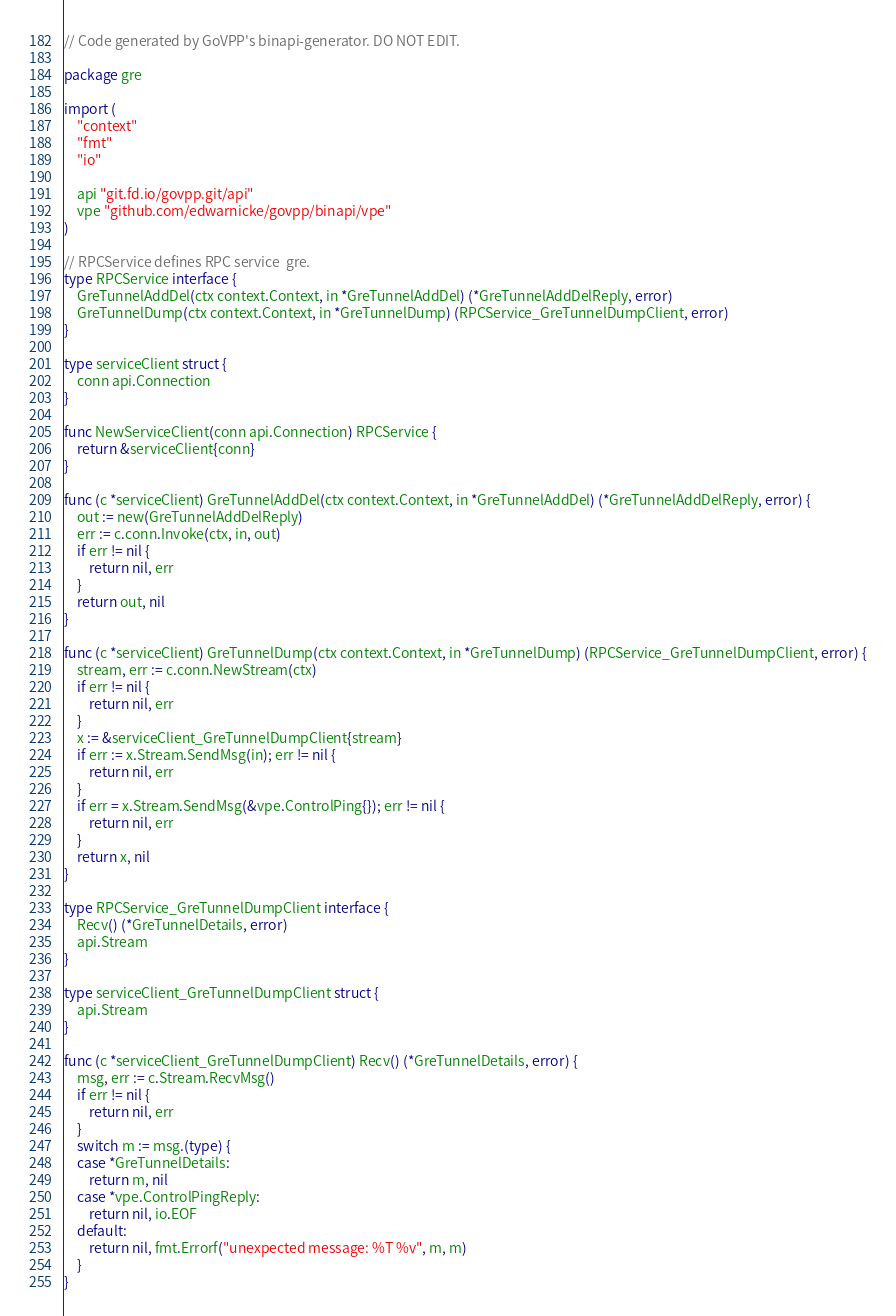<code> <loc_0><loc_0><loc_500><loc_500><_Go_>// Code generated by GoVPP's binapi-generator. DO NOT EDIT.

package gre

import (
	"context"
	"fmt"
	"io"

	api "git.fd.io/govpp.git/api"
	vpe "github.com/edwarnicke/govpp/binapi/vpe"
)

// RPCService defines RPC service  gre.
type RPCService interface {
	GreTunnelAddDel(ctx context.Context, in *GreTunnelAddDel) (*GreTunnelAddDelReply, error)
	GreTunnelDump(ctx context.Context, in *GreTunnelDump) (RPCService_GreTunnelDumpClient, error)
}

type serviceClient struct {
	conn api.Connection
}

func NewServiceClient(conn api.Connection) RPCService {
	return &serviceClient{conn}
}

func (c *serviceClient) GreTunnelAddDel(ctx context.Context, in *GreTunnelAddDel) (*GreTunnelAddDelReply, error) {
	out := new(GreTunnelAddDelReply)
	err := c.conn.Invoke(ctx, in, out)
	if err != nil {
		return nil, err
	}
	return out, nil
}

func (c *serviceClient) GreTunnelDump(ctx context.Context, in *GreTunnelDump) (RPCService_GreTunnelDumpClient, error) {
	stream, err := c.conn.NewStream(ctx)
	if err != nil {
		return nil, err
	}
	x := &serviceClient_GreTunnelDumpClient{stream}
	if err := x.Stream.SendMsg(in); err != nil {
		return nil, err
	}
	if err = x.Stream.SendMsg(&vpe.ControlPing{}); err != nil {
		return nil, err
	}
	return x, nil
}

type RPCService_GreTunnelDumpClient interface {
	Recv() (*GreTunnelDetails, error)
	api.Stream
}

type serviceClient_GreTunnelDumpClient struct {
	api.Stream
}

func (c *serviceClient_GreTunnelDumpClient) Recv() (*GreTunnelDetails, error) {
	msg, err := c.Stream.RecvMsg()
	if err != nil {
		return nil, err
	}
	switch m := msg.(type) {
	case *GreTunnelDetails:
		return m, nil
	case *vpe.ControlPingReply:
		return nil, io.EOF
	default:
		return nil, fmt.Errorf("unexpected message: %T %v", m, m)
	}
}
</code> 